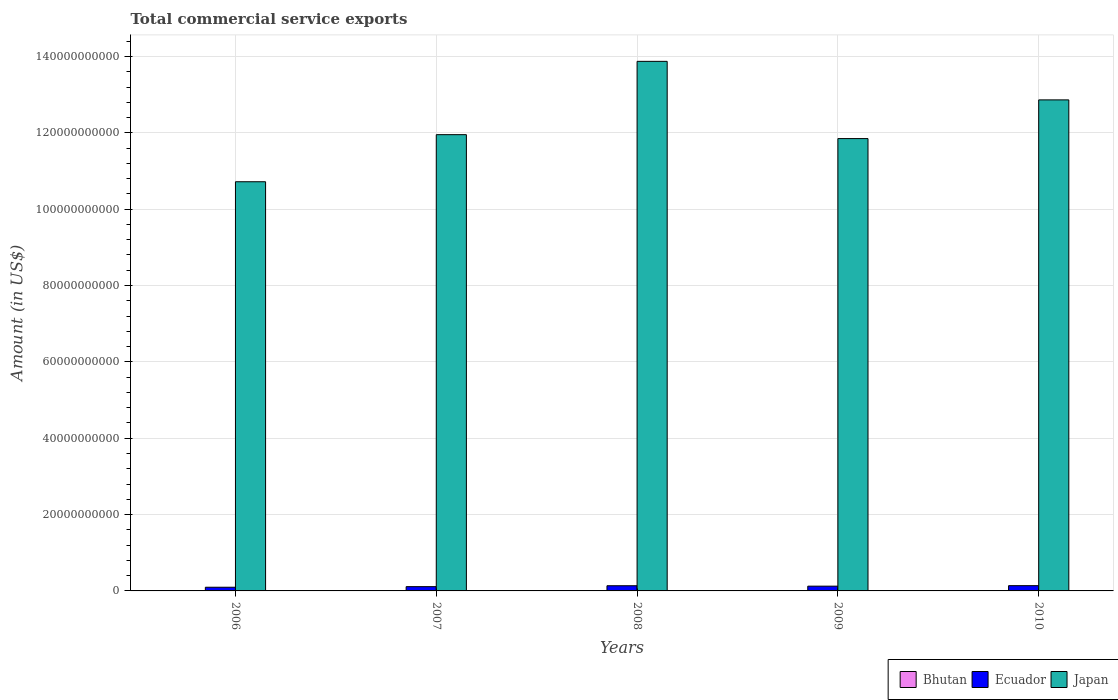Are the number of bars per tick equal to the number of legend labels?
Provide a short and direct response. Yes. How many bars are there on the 5th tick from the left?
Provide a succinct answer. 3. What is the label of the 5th group of bars from the left?
Offer a very short reply. 2010. What is the total commercial service exports in Ecuador in 2006?
Provide a short and direct response. 9.65e+08. Across all years, what is the maximum total commercial service exports in Ecuador?
Ensure brevity in your answer.  1.38e+09. Across all years, what is the minimum total commercial service exports in Japan?
Provide a succinct answer. 1.07e+11. In which year was the total commercial service exports in Bhutan minimum?
Keep it short and to the point. 2006. What is the total total commercial service exports in Bhutan in the graph?
Offer a terse response. 2.65e+08. What is the difference between the total commercial service exports in Ecuador in 2007 and that in 2009?
Give a very brief answer. -1.27e+08. What is the difference between the total commercial service exports in Japan in 2007 and the total commercial service exports in Ecuador in 2006?
Keep it short and to the point. 1.19e+11. What is the average total commercial service exports in Japan per year?
Your answer should be very brief. 1.23e+11. In the year 2008, what is the difference between the total commercial service exports in Ecuador and total commercial service exports in Japan?
Offer a very short reply. -1.37e+11. In how many years, is the total commercial service exports in Japan greater than 96000000000 US$?
Give a very brief answer. 5. What is the ratio of the total commercial service exports in Bhutan in 2006 to that in 2009?
Provide a short and direct response. 0.79. Is the difference between the total commercial service exports in Ecuador in 2006 and 2009 greater than the difference between the total commercial service exports in Japan in 2006 and 2009?
Ensure brevity in your answer.  Yes. What is the difference between the highest and the second highest total commercial service exports in Japan?
Provide a short and direct response. 1.01e+1. What is the difference between the highest and the lowest total commercial service exports in Japan?
Offer a terse response. 3.15e+1. Is the sum of the total commercial service exports in Ecuador in 2006 and 2007 greater than the maximum total commercial service exports in Bhutan across all years?
Your answer should be very brief. Yes. What does the 3rd bar from the left in 2009 represents?
Your response must be concise. Japan. What does the 1st bar from the right in 2007 represents?
Ensure brevity in your answer.  Japan. Are all the bars in the graph horizontal?
Offer a very short reply. No. What is the difference between two consecutive major ticks on the Y-axis?
Make the answer very short. 2.00e+1. Does the graph contain any zero values?
Provide a succinct answer. No. What is the title of the graph?
Keep it short and to the point. Total commercial service exports. Does "South Sudan" appear as one of the legend labels in the graph?
Provide a succinct answer. No. What is the label or title of the X-axis?
Your answer should be very brief. Years. What is the Amount (in US$) in Bhutan in 2006?
Give a very brief answer. 4.20e+07. What is the Amount (in US$) of Ecuador in 2006?
Give a very brief answer. 9.65e+08. What is the Amount (in US$) in Japan in 2006?
Your answer should be compact. 1.07e+11. What is the Amount (in US$) of Bhutan in 2007?
Provide a succinct answer. 5.18e+07. What is the Amount (in US$) of Ecuador in 2007?
Ensure brevity in your answer.  1.12e+09. What is the Amount (in US$) of Japan in 2007?
Provide a short and direct response. 1.20e+11. What is the Amount (in US$) in Bhutan in 2008?
Your answer should be compact. 5.07e+07. What is the Amount (in US$) in Ecuador in 2008?
Your answer should be compact. 1.36e+09. What is the Amount (in US$) of Japan in 2008?
Your answer should be very brief. 1.39e+11. What is the Amount (in US$) in Bhutan in 2009?
Offer a terse response. 5.33e+07. What is the Amount (in US$) of Ecuador in 2009?
Your answer should be compact. 1.24e+09. What is the Amount (in US$) of Japan in 2009?
Your answer should be very brief. 1.18e+11. What is the Amount (in US$) of Bhutan in 2010?
Provide a succinct answer. 6.69e+07. What is the Amount (in US$) of Ecuador in 2010?
Keep it short and to the point. 1.38e+09. What is the Amount (in US$) in Japan in 2010?
Your response must be concise. 1.29e+11. Across all years, what is the maximum Amount (in US$) in Bhutan?
Give a very brief answer. 6.69e+07. Across all years, what is the maximum Amount (in US$) of Ecuador?
Your answer should be very brief. 1.38e+09. Across all years, what is the maximum Amount (in US$) of Japan?
Your response must be concise. 1.39e+11. Across all years, what is the minimum Amount (in US$) in Bhutan?
Give a very brief answer. 4.20e+07. Across all years, what is the minimum Amount (in US$) of Ecuador?
Your answer should be very brief. 9.65e+08. Across all years, what is the minimum Amount (in US$) in Japan?
Your response must be concise. 1.07e+11. What is the total Amount (in US$) of Bhutan in the graph?
Provide a succinct answer. 2.65e+08. What is the total Amount (in US$) of Ecuador in the graph?
Ensure brevity in your answer.  6.06e+09. What is the total Amount (in US$) of Japan in the graph?
Provide a succinct answer. 6.13e+11. What is the difference between the Amount (in US$) of Bhutan in 2006 and that in 2007?
Ensure brevity in your answer.  -9.80e+06. What is the difference between the Amount (in US$) in Ecuador in 2006 and that in 2007?
Your answer should be compact. -1.53e+08. What is the difference between the Amount (in US$) in Japan in 2006 and that in 2007?
Your response must be concise. -1.23e+1. What is the difference between the Amount (in US$) of Bhutan in 2006 and that in 2008?
Your response must be concise. -8.72e+06. What is the difference between the Amount (in US$) in Ecuador in 2006 and that in 2008?
Your answer should be compact. -3.93e+08. What is the difference between the Amount (in US$) in Japan in 2006 and that in 2008?
Your response must be concise. -3.15e+1. What is the difference between the Amount (in US$) of Bhutan in 2006 and that in 2009?
Your answer should be very brief. -1.13e+07. What is the difference between the Amount (in US$) of Ecuador in 2006 and that in 2009?
Provide a short and direct response. -2.80e+08. What is the difference between the Amount (in US$) in Japan in 2006 and that in 2009?
Provide a short and direct response. -1.13e+1. What is the difference between the Amount (in US$) of Bhutan in 2006 and that in 2010?
Provide a succinct answer. -2.49e+07. What is the difference between the Amount (in US$) of Ecuador in 2006 and that in 2010?
Make the answer very short. -4.11e+08. What is the difference between the Amount (in US$) of Japan in 2006 and that in 2010?
Your response must be concise. -2.14e+1. What is the difference between the Amount (in US$) in Bhutan in 2007 and that in 2008?
Give a very brief answer. 1.08e+06. What is the difference between the Amount (in US$) of Ecuador in 2007 and that in 2008?
Make the answer very short. -2.39e+08. What is the difference between the Amount (in US$) of Japan in 2007 and that in 2008?
Provide a short and direct response. -1.92e+1. What is the difference between the Amount (in US$) in Bhutan in 2007 and that in 2009?
Offer a terse response. -1.45e+06. What is the difference between the Amount (in US$) of Ecuador in 2007 and that in 2009?
Your response must be concise. -1.27e+08. What is the difference between the Amount (in US$) of Japan in 2007 and that in 2009?
Offer a very short reply. 1.03e+09. What is the difference between the Amount (in US$) of Bhutan in 2007 and that in 2010?
Give a very brief answer. -1.51e+07. What is the difference between the Amount (in US$) of Ecuador in 2007 and that in 2010?
Offer a terse response. -2.57e+08. What is the difference between the Amount (in US$) of Japan in 2007 and that in 2010?
Keep it short and to the point. -9.11e+09. What is the difference between the Amount (in US$) in Bhutan in 2008 and that in 2009?
Make the answer very short. -2.53e+06. What is the difference between the Amount (in US$) in Ecuador in 2008 and that in 2009?
Offer a terse response. 1.13e+08. What is the difference between the Amount (in US$) of Japan in 2008 and that in 2009?
Keep it short and to the point. 2.02e+1. What is the difference between the Amount (in US$) in Bhutan in 2008 and that in 2010?
Offer a very short reply. -1.62e+07. What is the difference between the Amount (in US$) in Ecuador in 2008 and that in 2010?
Ensure brevity in your answer.  -1.81e+07. What is the difference between the Amount (in US$) in Japan in 2008 and that in 2010?
Your answer should be compact. 1.01e+1. What is the difference between the Amount (in US$) in Bhutan in 2009 and that in 2010?
Your answer should be compact. -1.36e+07. What is the difference between the Amount (in US$) of Ecuador in 2009 and that in 2010?
Provide a short and direct response. -1.31e+08. What is the difference between the Amount (in US$) of Japan in 2009 and that in 2010?
Make the answer very short. -1.01e+1. What is the difference between the Amount (in US$) in Bhutan in 2006 and the Amount (in US$) in Ecuador in 2007?
Your answer should be very brief. -1.08e+09. What is the difference between the Amount (in US$) in Bhutan in 2006 and the Amount (in US$) in Japan in 2007?
Offer a terse response. -1.19e+11. What is the difference between the Amount (in US$) in Ecuador in 2006 and the Amount (in US$) in Japan in 2007?
Make the answer very short. -1.19e+11. What is the difference between the Amount (in US$) of Bhutan in 2006 and the Amount (in US$) of Ecuador in 2008?
Give a very brief answer. -1.32e+09. What is the difference between the Amount (in US$) of Bhutan in 2006 and the Amount (in US$) of Japan in 2008?
Provide a short and direct response. -1.39e+11. What is the difference between the Amount (in US$) of Ecuador in 2006 and the Amount (in US$) of Japan in 2008?
Your answer should be compact. -1.38e+11. What is the difference between the Amount (in US$) in Bhutan in 2006 and the Amount (in US$) in Ecuador in 2009?
Your answer should be compact. -1.20e+09. What is the difference between the Amount (in US$) of Bhutan in 2006 and the Amount (in US$) of Japan in 2009?
Your answer should be very brief. -1.18e+11. What is the difference between the Amount (in US$) in Ecuador in 2006 and the Amount (in US$) in Japan in 2009?
Your answer should be compact. -1.18e+11. What is the difference between the Amount (in US$) in Bhutan in 2006 and the Amount (in US$) in Ecuador in 2010?
Offer a very short reply. -1.33e+09. What is the difference between the Amount (in US$) in Bhutan in 2006 and the Amount (in US$) in Japan in 2010?
Your answer should be compact. -1.29e+11. What is the difference between the Amount (in US$) of Ecuador in 2006 and the Amount (in US$) of Japan in 2010?
Provide a succinct answer. -1.28e+11. What is the difference between the Amount (in US$) of Bhutan in 2007 and the Amount (in US$) of Ecuador in 2008?
Ensure brevity in your answer.  -1.31e+09. What is the difference between the Amount (in US$) of Bhutan in 2007 and the Amount (in US$) of Japan in 2008?
Your answer should be very brief. -1.39e+11. What is the difference between the Amount (in US$) in Ecuador in 2007 and the Amount (in US$) in Japan in 2008?
Your answer should be very brief. -1.38e+11. What is the difference between the Amount (in US$) of Bhutan in 2007 and the Amount (in US$) of Ecuador in 2009?
Keep it short and to the point. -1.19e+09. What is the difference between the Amount (in US$) in Bhutan in 2007 and the Amount (in US$) in Japan in 2009?
Provide a short and direct response. -1.18e+11. What is the difference between the Amount (in US$) of Ecuador in 2007 and the Amount (in US$) of Japan in 2009?
Offer a terse response. -1.17e+11. What is the difference between the Amount (in US$) in Bhutan in 2007 and the Amount (in US$) in Ecuador in 2010?
Make the answer very short. -1.32e+09. What is the difference between the Amount (in US$) in Bhutan in 2007 and the Amount (in US$) in Japan in 2010?
Provide a succinct answer. -1.29e+11. What is the difference between the Amount (in US$) of Ecuador in 2007 and the Amount (in US$) of Japan in 2010?
Ensure brevity in your answer.  -1.28e+11. What is the difference between the Amount (in US$) of Bhutan in 2008 and the Amount (in US$) of Ecuador in 2009?
Ensure brevity in your answer.  -1.19e+09. What is the difference between the Amount (in US$) in Bhutan in 2008 and the Amount (in US$) in Japan in 2009?
Provide a succinct answer. -1.18e+11. What is the difference between the Amount (in US$) of Ecuador in 2008 and the Amount (in US$) of Japan in 2009?
Keep it short and to the point. -1.17e+11. What is the difference between the Amount (in US$) of Bhutan in 2008 and the Amount (in US$) of Ecuador in 2010?
Make the answer very short. -1.32e+09. What is the difference between the Amount (in US$) of Bhutan in 2008 and the Amount (in US$) of Japan in 2010?
Offer a terse response. -1.29e+11. What is the difference between the Amount (in US$) in Ecuador in 2008 and the Amount (in US$) in Japan in 2010?
Your answer should be compact. -1.27e+11. What is the difference between the Amount (in US$) of Bhutan in 2009 and the Amount (in US$) of Ecuador in 2010?
Your response must be concise. -1.32e+09. What is the difference between the Amount (in US$) of Bhutan in 2009 and the Amount (in US$) of Japan in 2010?
Keep it short and to the point. -1.29e+11. What is the difference between the Amount (in US$) of Ecuador in 2009 and the Amount (in US$) of Japan in 2010?
Keep it short and to the point. -1.27e+11. What is the average Amount (in US$) in Bhutan per year?
Your answer should be compact. 5.29e+07. What is the average Amount (in US$) in Ecuador per year?
Provide a short and direct response. 1.21e+09. What is the average Amount (in US$) in Japan per year?
Provide a short and direct response. 1.23e+11. In the year 2006, what is the difference between the Amount (in US$) in Bhutan and Amount (in US$) in Ecuador?
Ensure brevity in your answer.  -9.23e+08. In the year 2006, what is the difference between the Amount (in US$) of Bhutan and Amount (in US$) of Japan?
Make the answer very short. -1.07e+11. In the year 2006, what is the difference between the Amount (in US$) of Ecuador and Amount (in US$) of Japan?
Provide a succinct answer. -1.06e+11. In the year 2007, what is the difference between the Amount (in US$) in Bhutan and Amount (in US$) in Ecuador?
Ensure brevity in your answer.  -1.07e+09. In the year 2007, what is the difference between the Amount (in US$) of Bhutan and Amount (in US$) of Japan?
Make the answer very short. -1.19e+11. In the year 2007, what is the difference between the Amount (in US$) of Ecuador and Amount (in US$) of Japan?
Offer a terse response. -1.18e+11. In the year 2008, what is the difference between the Amount (in US$) in Bhutan and Amount (in US$) in Ecuador?
Offer a terse response. -1.31e+09. In the year 2008, what is the difference between the Amount (in US$) of Bhutan and Amount (in US$) of Japan?
Your response must be concise. -1.39e+11. In the year 2008, what is the difference between the Amount (in US$) in Ecuador and Amount (in US$) in Japan?
Make the answer very short. -1.37e+11. In the year 2009, what is the difference between the Amount (in US$) of Bhutan and Amount (in US$) of Ecuador?
Provide a succinct answer. -1.19e+09. In the year 2009, what is the difference between the Amount (in US$) of Bhutan and Amount (in US$) of Japan?
Provide a short and direct response. -1.18e+11. In the year 2009, what is the difference between the Amount (in US$) of Ecuador and Amount (in US$) of Japan?
Your answer should be compact. -1.17e+11. In the year 2010, what is the difference between the Amount (in US$) of Bhutan and Amount (in US$) of Ecuador?
Provide a short and direct response. -1.31e+09. In the year 2010, what is the difference between the Amount (in US$) in Bhutan and Amount (in US$) in Japan?
Your response must be concise. -1.29e+11. In the year 2010, what is the difference between the Amount (in US$) in Ecuador and Amount (in US$) in Japan?
Offer a very short reply. -1.27e+11. What is the ratio of the Amount (in US$) in Bhutan in 2006 to that in 2007?
Provide a short and direct response. 0.81. What is the ratio of the Amount (in US$) of Ecuador in 2006 to that in 2007?
Ensure brevity in your answer.  0.86. What is the ratio of the Amount (in US$) in Japan in 2006 to that in 2007?
Offer a terse response. 0.9. What is the ratio of the Amount (in US$) of Bhutan in 2006 to that in 2008?
Give a very brief answer. 0.83. What is the ratio of the Amount (in US$) of Ecuador in 2006 to that in 2008?
Ensure brevity in your answer.  0.71. What is the ratio of the Amount (in US$) of Japan in 2006 to that in 2008?
Give a very brief answer. 0.77. What is the ratio of the Amount (in US$) in Bhutan in 2006 to that in 2009?
Your response must be concise. 0.79. What is the ratio of the Amount (in US$) of Ecuador in 2006 to that in 2009?
Ensure brevity in your answer.  0.78. What is the ratio of the Amount (in US$) in Japan in 2006 to that in 2009?
Provide a short and direct response. 0.9. What is the ratio of the Amount (in US$) in Bhutan in 2006 to that in 2010?
Make the answer very short. 0.63. What is the ratio of the Amount (in US$) in Ecuador in 2006 to that in 2010?
Provide a succinct answer. 0.7. What is the ratio of the Amount (in US$) of Japan in 2006 to that in 2010?
Give a very brief answer. 0.83. What is the ratio of the Amount (in US$) in Bhutan in 2007 to that in 2008?
Keep it short and to the point. 1.02. What is the ratio of the Amount (in US$) of Ecuador in 2007 to that in 2008?
Give a very brief answer. 0.82. What is the ratio of the Amount (in US$) of Japan in 2007 to that in 2008?
Make the answer very short. 0.86. What is the ratio of the Amount (in US$) of Bhutan in 2007 to that in 2009?
Provide a succinct answer. 0.97. What is the ratio of the Amount (in US$) of Ecuador in 2007 to that in 2009?
Your answer should be very brief. 0.9. What is the ratio of the Amount (in US$) in Japan in 2007 to that in 2009?
Offer a very short reply. 1.01. What is the ratio of the Amount (in US$) of Bhutan in 2007 to that in 2010?
Offer a terse response. 0.77. What is the ratio of the Amount (in US$) of Ecuador in 2007 to that in 2010?
Offer a terse response. 0.81. What is the ratio of the Amount (in US$) in Japan in 2007 to that in 2010?
Offer a terse response. 0.93. What is the ratio of the Amount (in US$) of Ecuador in 2008 to that in 2009?
Ensure brevity in your answer.  1.09. What is the ratio of the Amount (in US$) of Japan in 2008 to that in 2009?
Offer a terse response. 1.17. What is the ratio of the Amount (in US$) of Bhutan in 2008 to that in 2010?
Provide a succinct answer. 0.76. What is the ratio of the Amount (in US$) in Ecuador in 2008 to that in 2010?
Give a very brief answer. 0.99. What is the ratio of the Amount (in US$) of Japan in 2008 to that in 2010?
Your answer should be compact. 1.08. What is the ratio of the Amount (in US$) of Bhutan in 2009 to that in 2010?
Offer a terse response. 0.8. What is the ratio of the Amount (in US$) of Ecuador in 2009 to that in 2010?
Make the answer very short. 0.91. What is the ratio of the Amount (in US$) in Japan in 2009 to that in 2010?
Your answer should be very brief. 0.92. What is the difference between the highest and the second highest Amount (in US$) in Bhutan?
Your answer should be very brief. 1.36e+07. What is the difference between the highest and the second highest Amount (in US$) of Ecuador?
Give a very brief answer. 1.81e+07. What is the difference between the highest and the second highest Amount (in US$) of Japan?
Provide a succinct answer. 1.01e+1. What is the difference between the highest and the lowest Amount (in US$) in Bhutan?
Provide a short and direct response. 2.49e+07. What is the difference between the highest and the lowest Amount (in US$) in Ecuador?
Your answer should be compact. 4.11e+08. What is the difference between the highest and the lowest Amount (in US$) of Japan?
Offer a very short reply. 3.15e+1. 